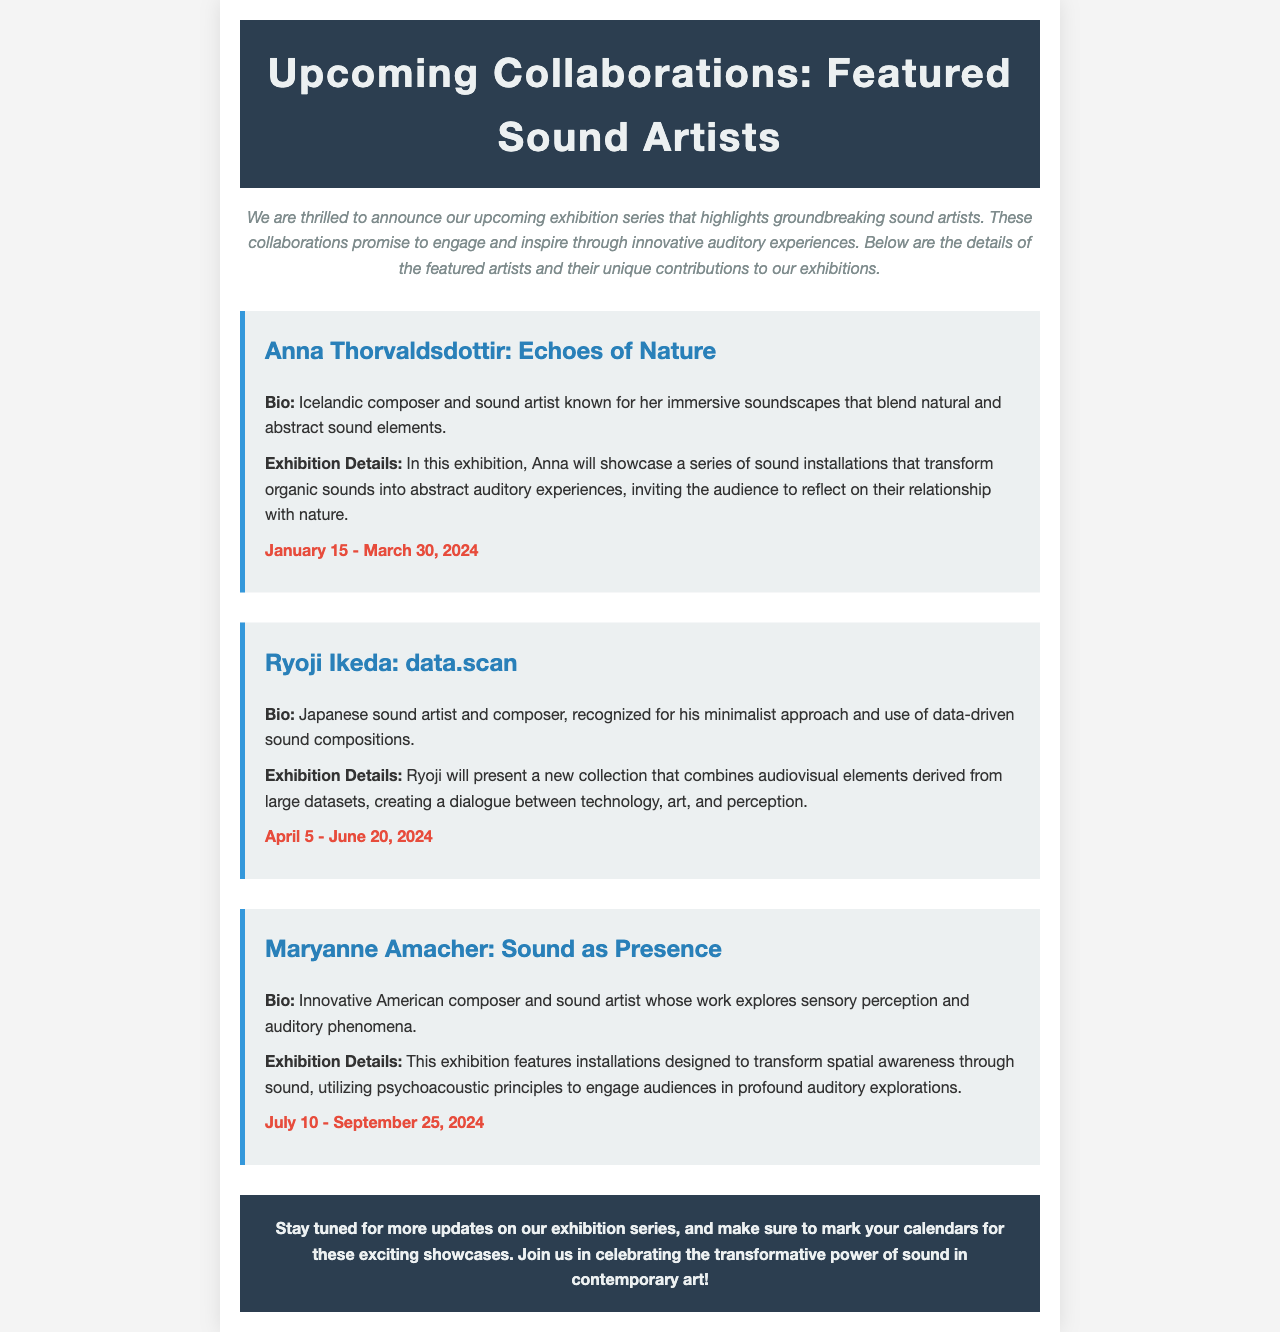What is the title of the exhibition series? The title of the exhibition series is mentioned at the top of the newsletter.
Answer: Upcoming Collaborations: Featured Sound Artists Who is the first featured sound artist? The first featured sound artist is listed in the newsletter with their exhibition details.
Answer: Anna Thorvaldsdottir What are the dates for Ryoji Ikeda's exhibition? The dates can be found in the section dedicated to Ryoji Ikeda's exhibition details.
Answer: April 5 - June 20, 2024 What is the main focus of Maryanne Amacher's installations? The focus is provided in the exhibition details about her work and what it aims to achieve.
Answer: Transform spatial awareness through sound How many featured sound artists are mentioned in the document? The number of artists can be calculated based on the distinct sections in the newsletter.
Answer: Three What innovative aspect does Ryoji Ikeda incorporate in his work? The relevant section describes his use of data-driven sound compositions.
Answer: Minimalist approach and data-driven sound compositions When does Anna Thorvaldsdottir's exhibition begin? This information is specified directly in the dates section under her exhibition details.
Answer: January 15, 2024 What is emphasized in the conclusion of the newsletter? The conclusion summarizes the overarching theme of the exhibitions and what to expect.
Answer: Transformative power of sound in contemporary art What type of experience does Anna Thorvaldsdottir's work invite the audience to reflect on? The description of her exhibition provides insight into the nature of the experience she creates.
Answer: Relationship with nature 